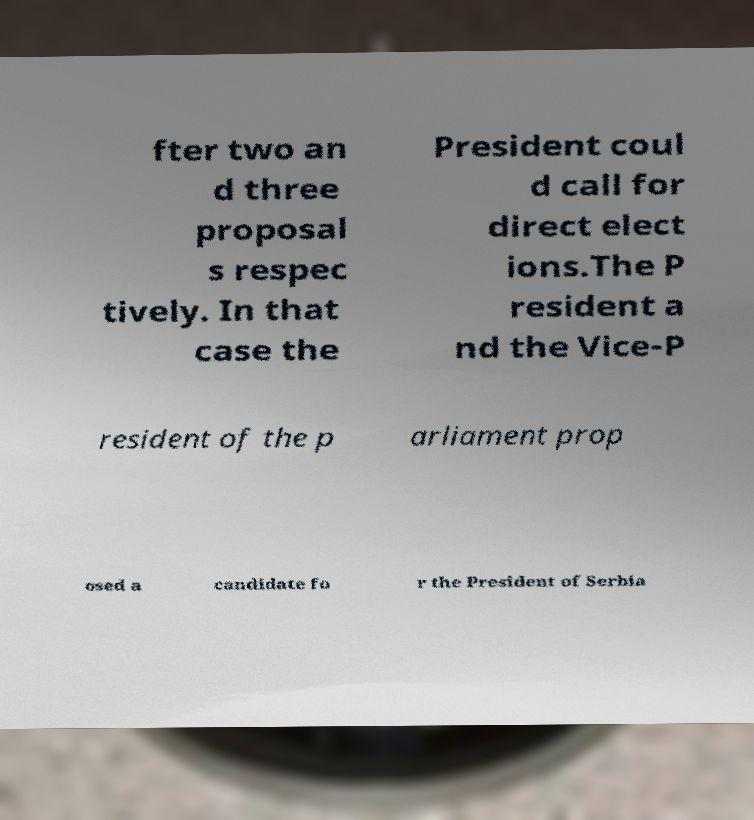Could you assist in decoding the text presented in this image and type it out clearly? fter two an d three proposal s respec tively. In that case the President coul d call for direct elect ions.The P resident a nd the Vice-P resident of the p arliament prop osed a candidate fo r the President of Serbia 